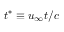Convert formula to latex. <formula><loc_0><loc_0><loc_500><loc_500>t ^ { * } \equiv u _ { \infty } t / c</formula> 